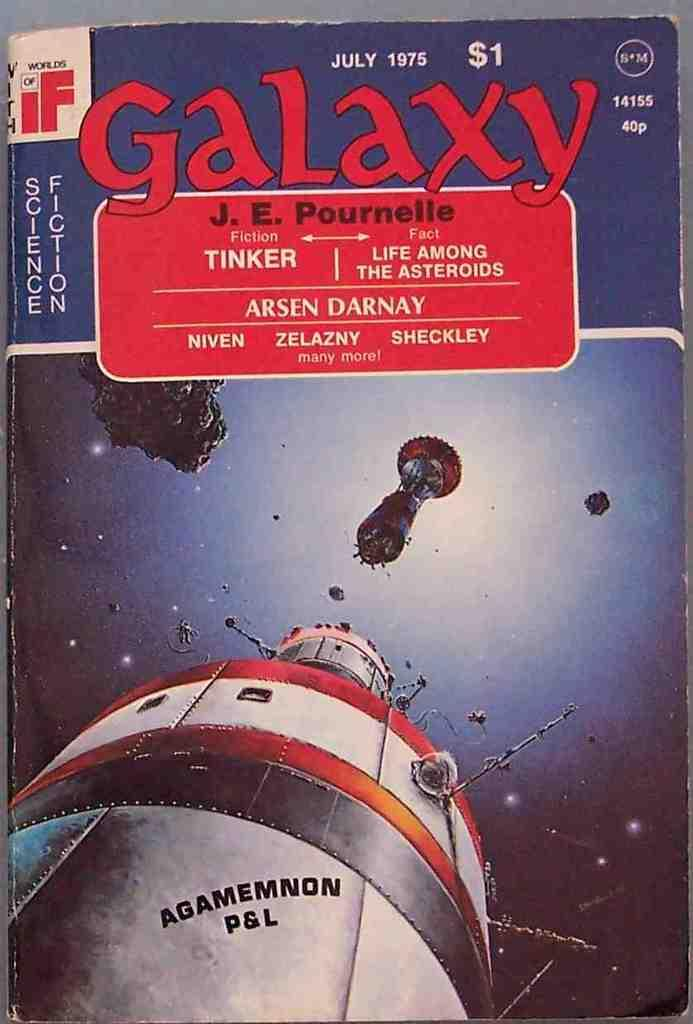<image>
Relay a brief, clear account of the picture shown. a book that says july 1975 at the top and 'galaxy' written in red bold lettering 